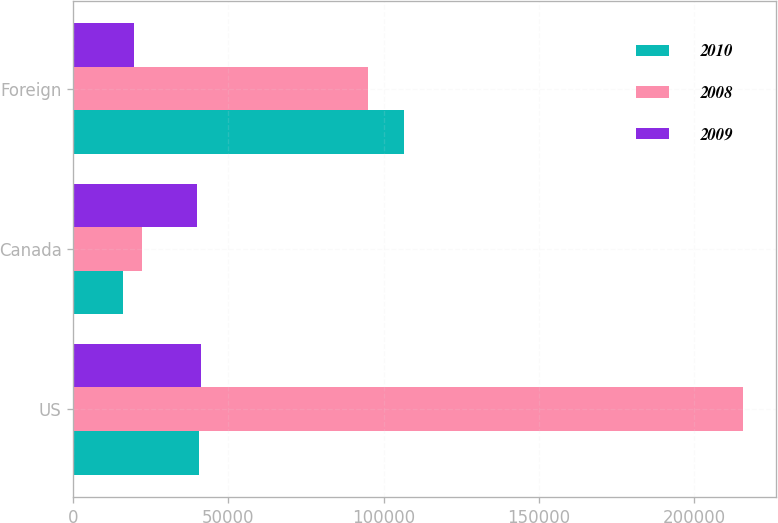<chart> <loc_0><loc_0><loc_500><loc_500><stacked_bar_chart><ecel><fcel>US<fcel>Canada<fcel>Foreign<nl><fcel>2010<fcel>40544.5<fcel>16128<fcel>106383<nl><fcel>2008<fcel>215594<fcel>22162<fcel>95077<nl><fcel>2009<fcel>41267<fcel>39822<fcel>19706<nl></chart> 